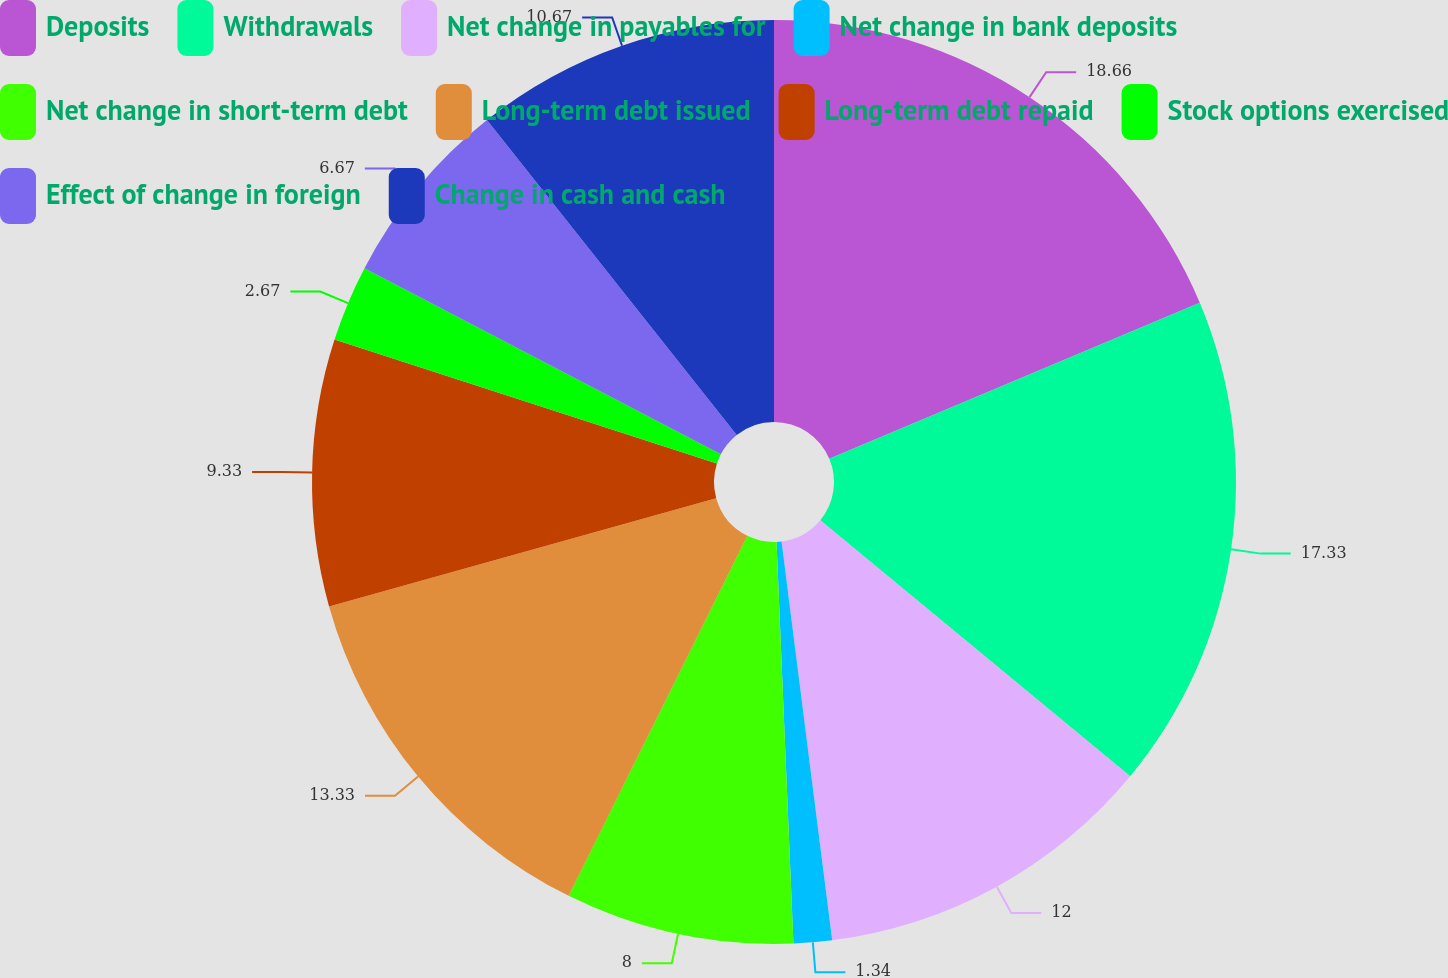Convert chart to OTSL. <chart><loc_0><loc_0><loc_500><loc_500><pie_chart><fcel>Deposits<fcel>Withdrawals<fcel>Net change in payables for<fcel>Net change in bank deposits<fcel>Net change in short-term debt<fcel>Long-term debt issued<fcel>Long-term debt repaid<fcel>Stock options exercised<fcel>Effect of change in foreign<fcel>Change in cash and cash<nl><fcel>18.66%<fcel>17.33%<fcel>12.0%<fcel>1.34%<fcel>8.0%<fcel>13.33%<fcel>9.33%<fcel>2.67%<fcel>6.67%<fcel>10.67%<nl></chart> 